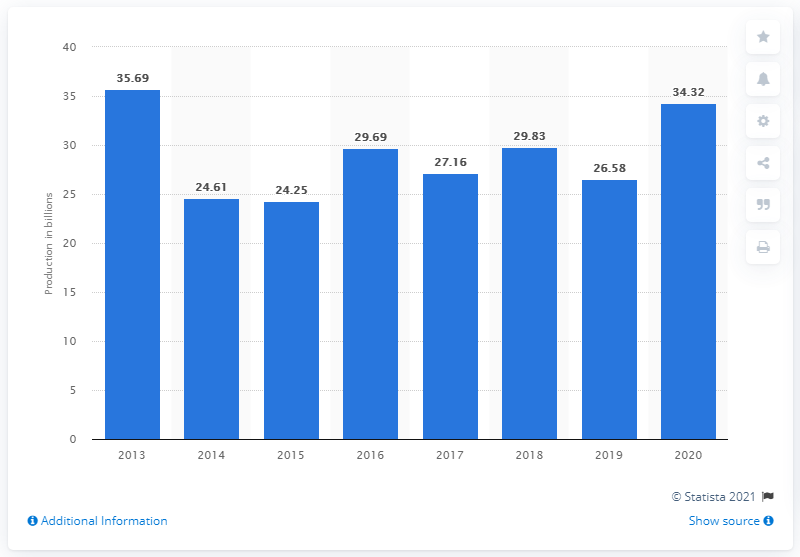Specify some key components in this picture. In 2013, the highest number of circuits was produced in Malaysia. In 2020, a total of 34,320 integrated circuits were produced in Malaysia. 